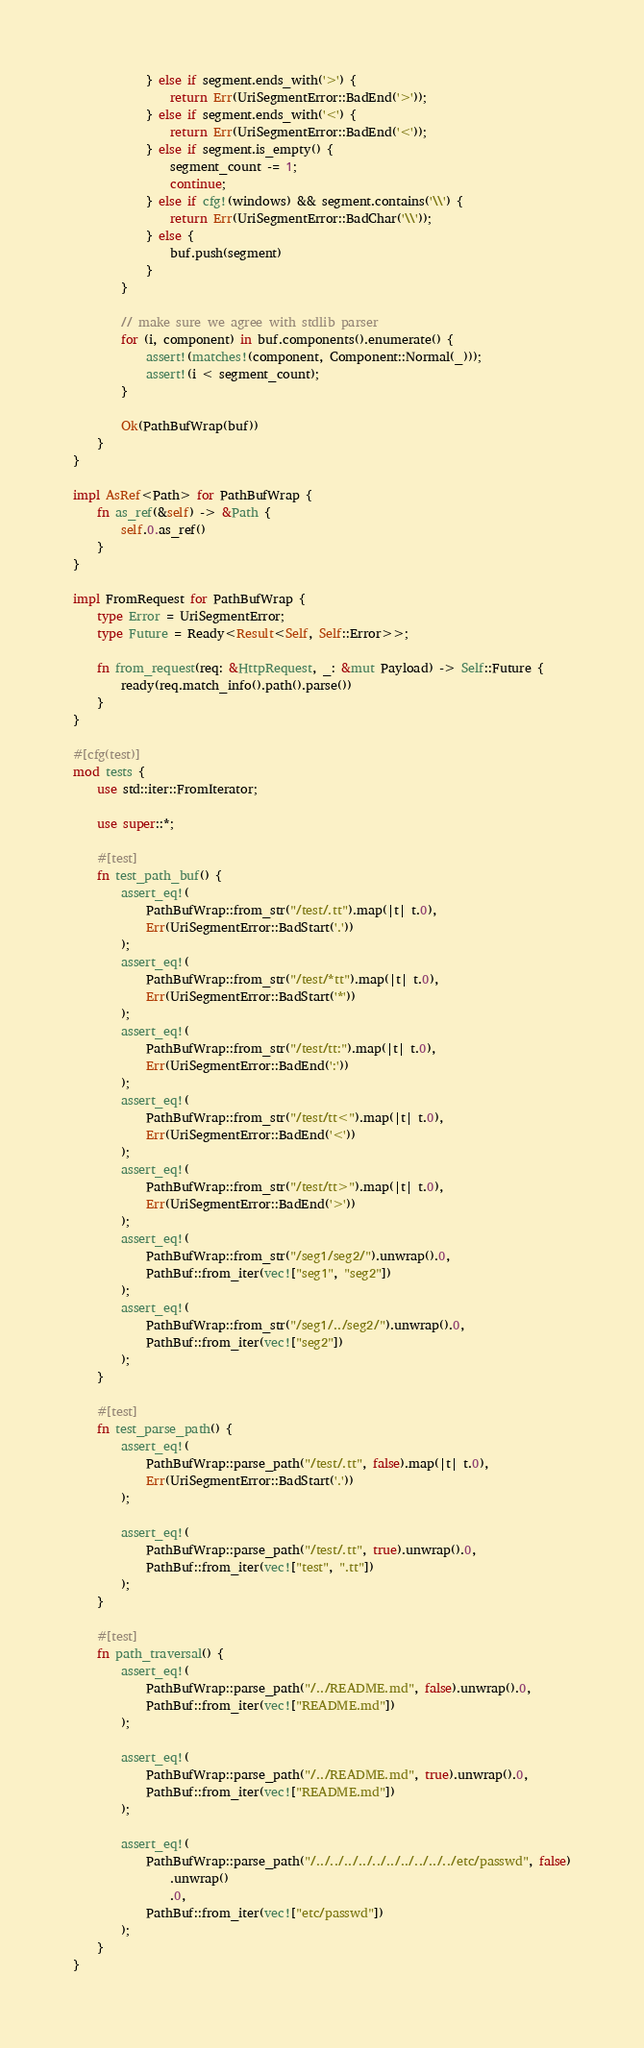<code> <loc_0><loc_0><loc_500><loc_500><_Rust_>            } else if segment.ends_with('>') {
                return Err(UriSegmentError::BadEnd('>'));
            } else if segment.ends_with('<') {
                return Err(UriSegmentError::BadEnd('<'));
            } else if segment.is_empty() {
                segment_count -= 1;
                continue;
            } else if cfg!(windows) && segment.contains('\\') {
                return Err(UriSegmentError::BadChar('\\'));
            } else {
                buf.push(segment)
            }
        }

        // make sure we agree with stdlib parser
        for (i, component) in buf.components().enumerate() {
            assert!(matches!(component, Component::Normal(_)));
            assert!(i < segment_count);
        }

        Ok(PathBufWrap(buf))
    }
}

impl AsRef<Path> for PathBufWrap {
    fn as_ref(&self) -> &Path {
        self.0.as_ref()
    }
}

impl FromRequest for PathBufWrap {
    type Error = UriSegmentError;
    type Future = Ready<Result<Self, Self::Error>>;

    fn from_request(req: &HttpRequest, _: &mut Payload) -> Self::Future {
        ready(req.match_info().path().parse())
    }
}

#[cfg(test)]
mod tests {
    use std::iter::FromIterator;

    use super::*;

    #[test]
    fn test_path_buf() {
        assert_eq!(
            PathBufWrap::from_str("/test/.tt").map(|t| t.0),
            Err(UriSegmentError::BadStart('.'))
        );
        assert_eq!(
            PathBufWrap::from_str("/test/*tt").map(|t| t.0),
            Err(UriSegmentError::BadStart('*'))
        );
        assert_eq!(
            PathBufWrap::from_str("/test/tt:").map(|t| t.0),
            Err(UriSegmentError::BadEnd(':'))
        );
        assert_eq!(
            PathBufWrap::from_str("/test/tt<").map(|t| t.0),
            Err(UriSegmentError::BadEnd('<'))
        );
        assert_eq!(
            PathBufWrap::from_str("/test/tt>").map(|t| t.0),
            Err(UriSegmentError::BadEnd('>'))
        );
        assert_eq!(
            PathBufWrap::from_str("/seg1/seg2/").unwrap().0,
            PathBuf::from_iter(vec!["seg1", "seg2"])
        );
        assert_eq!(
            PathBufWrap::from_str("/seg1/../seg2/").unwrap().0,
            PathBuf::from_iter(vec!["seg2"])
        );
    }

    #[test]
    fn test_parse_path() {
        assert_eq!(
            PathBufWrap::parse_path("/test/.tt", false).map(|t| t.0),
            Err(UriSegmentError::BadStart('.'))
        );

        assert_eq!(
            PathBufWrap::parse_path("/test/.tt", true).unwrap().0,
            PathBuf::from_iter(vec!["test", ".tt"])
        );
    }

    #[test]
    fn path_traversal() {
        assert_eq!(
            PathBufWrap::parse_path("/../README.md", false).unwrap().0,
            PathBuf::from_iter(vec!["README.md"])
        );

        assert_eq!(
            PathBufWrap::parse_path("/../README.md", true).unwrap().0,
            PathBuf::from_iter(vec!["README.md"])
        );

        assert_eq!(
            PathBufWrap::parse_path("/../../../../../../../../../../etc/passwd", false)
                .unwrap()
                .0,
            PathBuf::from_iter(vec!["etc/passwd"])
        );
    }
}
</code> 